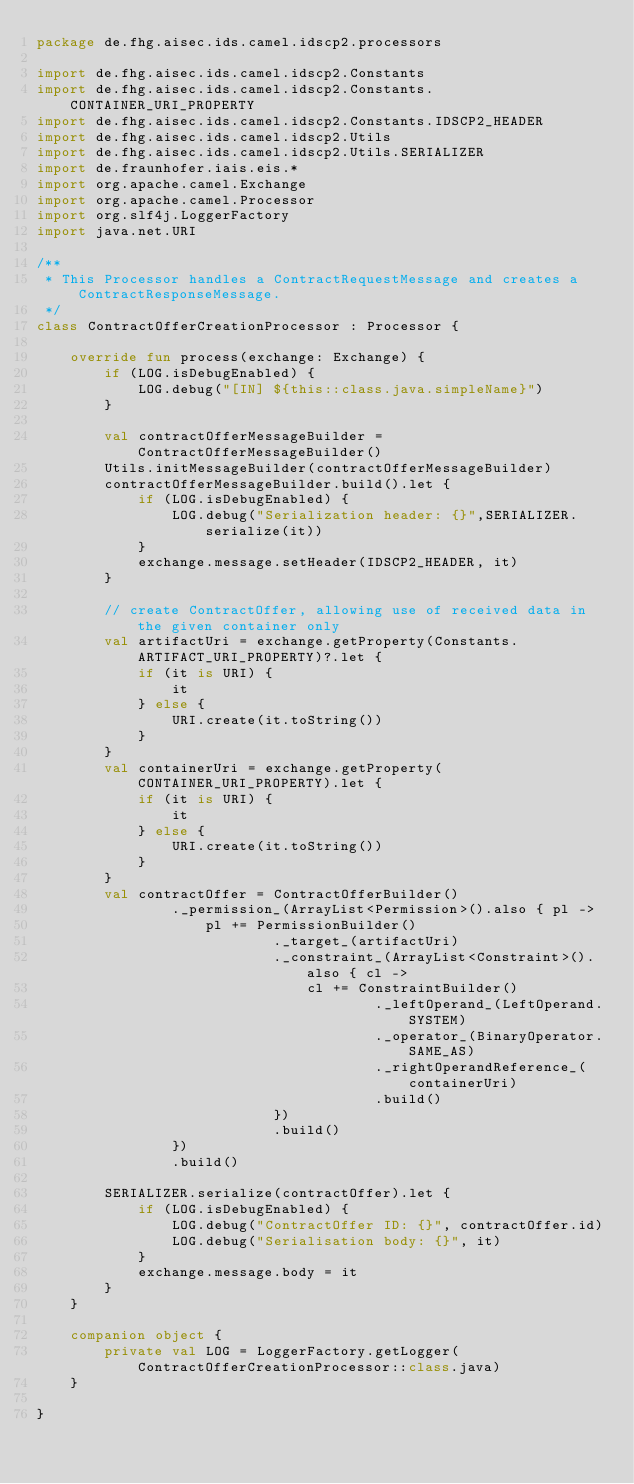Convert code to text. <code><loc_0><loc_0><loc_500><loc_500><_Kotlin_>package de.fhg.aisec.ids.camel.idscp2.processors

import de.fhg.aisec.ids.camel.idscp2.Constants
import de.fhg.aisec.ids.camel.idscp2.Constants.CONTAINER_URI_PROPERTY
import de.fhg.aisec.ids.camel.idscp2.Constants.IDSCP2_HEADER
import de.fhg.aisec.ids.camel.idscp2.Utils
import de.fhg.aisec.ids.camel.idscp2.Utils.SERIALIZER
import de.fraunhofer.iais.eis.*
import org.apache.camel.Exchange
import org.apache.camel.Processor
import org.slf4j.LoggerFactory
import java.net.URI

/**
 * This Processor handles a ContractRequestMessage and creates a ContractResponseMessage.
 */
class ContractOfferCreationProcessor : Processor {

    override fun process(exchange: Exchange) {
        if (LOG.isDebugEnabled) {
            LOG.debug("[IN] ${this::class.java.simpleName}")
        }

        val contractOfferMessageBuilder = ContractOfferMessageBuilder()
        Utils.initMessageBuilder(contractOfferMessageBuilder)
        contractOfferMessageBuilder.build().let {
            if (LOG.isDebugEnabled) {
                LOG.debug("Serialization header: {}",SERIALIZER.serialize(it))
            }
            exchange.message.setHeader(IDSCP2_HEADER, it)
        }

        // create ContractOffer, allowing use of received data in the given container only
        val artifactUri = exchange.getProperty(Constants.ARTIFACT_URI_PROPERTY)?.let {
            if (it is URI) {
                it
            } else {
                URI.create(it.toString())
            }
        }
        val containerUri = exchange.getProperty(CONTAINER_URI_PROPERTY).let {
            if (it is URI) {
                it
            } else {
                URI.create(it.toString())
            }
        }
        val contractOffer = ContractOfferBuilder()
                ._permission_(ArrayList<Permission>().also { pl ->
                    pl += PermissionBuilder()
                            ._target_(artifactUri)
                            ._constraint_(ArrayList<Constraint>().also { cl ->
                                cl += ConstraintBuilder()
                                        ._leftOperand_(LeftOperand.SYSTEM)
                                        ._operator_(BinaryOperator.SAME_AS)
                                        ._rightOperandReference_(containerUri)
                                        .build()
                            })
                            .build()
                })
                .build()

        SERIALIZER.serialize(contractOffer).let {
            if (LOG.isDebugEnabled) {
                LOG.debug("ContractOffer ID: {}", contractOffer.id)
                LOG.debug("Serialisation body: {}", it)
            }
            exchange.message.body = it
        }
    }

    companion object {
        private val LOG = LoggerFactory.getLogger(ContractOfferCreationProcessor::class.java)
    }

}</code> 